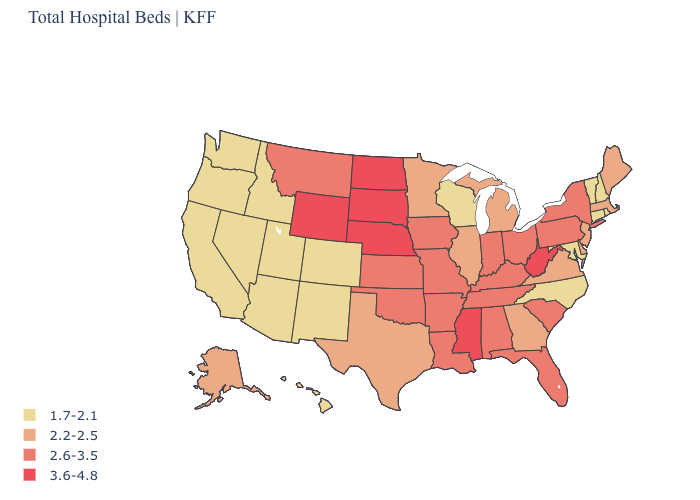What is the value of New Jersey?
Give a very brief answer. 2.2-2.5. How many symbols are there in the legend?
Answer briefly. 4. Which states have the lowest value in the USA?
Keep it brief. Arizona, California, Colorado, Connecticut, Hawaii, Idaho, Maryland, Nevada, New Hampshire, New Mexico, North Carolina, Oregon, Rhode Island, Utah, Vermont, Washington, Wisconsin. Does Massachusetts have the same value as Alaska?
Give a very brief answer. Yes. What is the value of Rhode Island?
Be succinct. 1.7-2.1. What is the lowest value in the USA?
Keep it brief. 1.7-2.1. What is the value of Alaska?
Be succinct. 2.2-2.5. What is the value of Washington?
Write a very short answer. 1.7-2.1. Name the states that have a value in the range 3.6-4.8?
Answer briefly. Mississippi, Nebraska, North Dakota, South Dakota, West Virginia, Wyoming. Does Missouri have the highest value in the USA?
Short answer required. No. What is the lowest value in states that border Alabama?
Be succinct. 2.2-2.5. Does Louisiana have the same value as Arkansas?
Be succinct. Yes. Does Montana have a lower value than North Dakota?
Keep it brief. Yes. Name the states that have a value in the range 2.6-3.5?
Quick response, please. Alabama, Arkansas, Florida, Indiana, Iowa, Kansas, Kentucky, Louisiana, Missouri, Montana, New York, Ohio, Oklahoma, Pennsylvania, South Carolina, Tennessee. 